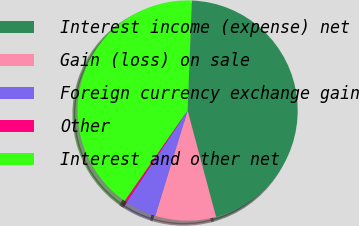<chart> <loc_0><loc_0><loc_500><loc_500><pie_chart><fcel>Interest income (expense) net<fcel>Gain (loss) on sale<fcel>Foreign currency exchange gain<fcel>Other<fcel>Interest and other net<nl><fcel>45.23%<fcel>8.89%<fcel>4.61%<fcel>0.33%<fcel>40.95%<nl></chart> 